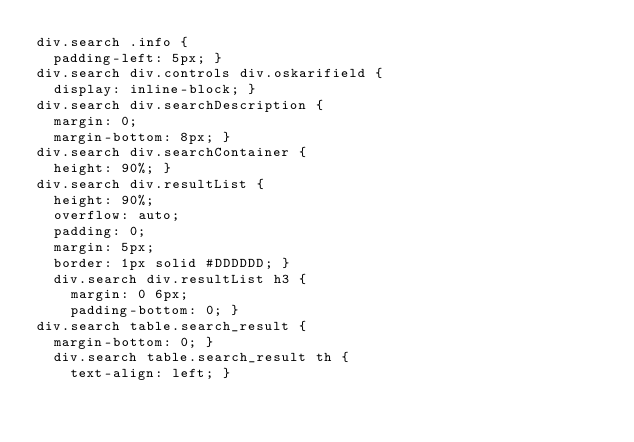<code> <loc_0><loc_0><loc_500><loc_500><_CSS_>div.search .info {
  padding-left: 5px; }
div.search div.controls div.oskarifield {
  display: inline-block; }
div.search div.searchDescription {
  margin: 0;
  margin-bottom: 8px; }
div.search div.searchContainer {
  height: 90%; }
div.search div.resultList {
  height: 90%;
  overflow: auto;
  padding: 0;
  margin: 5px;
  border: 1px solid #DDDDDD; }
  div.search div.resultList h3 {
    margin: 0 6px;
    padding-bottom: 0; }
div.search table.search_result {
  margin-bottom: 0; }
  div.search table.search_result th {
    text-align: left; }
</code> 